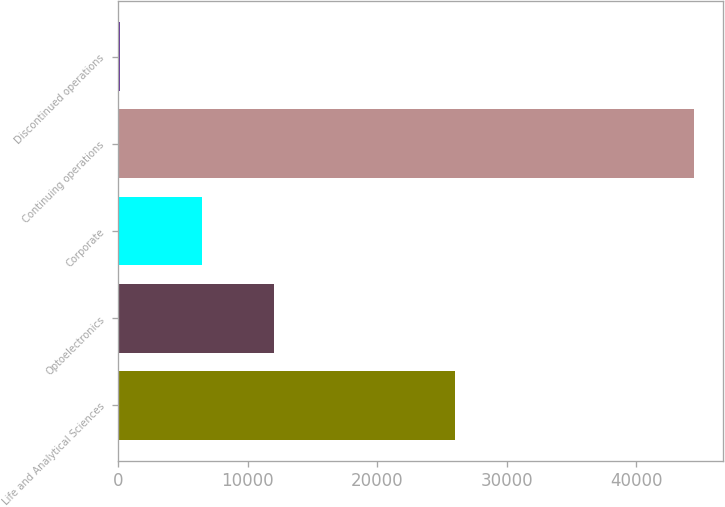<chart> <loc_0><loc_0><loc_500><loc_500><bar_chart><fcel>Life and Analytical Sciences<fcel>Optoelectronics<fcel>Corporate<fcel>Continuing operations<fcel>Discontinued operations<nl><fcel>25973<fcel>12003<fcel>6497<fcel>44473<fcel>109<nl></chart> 